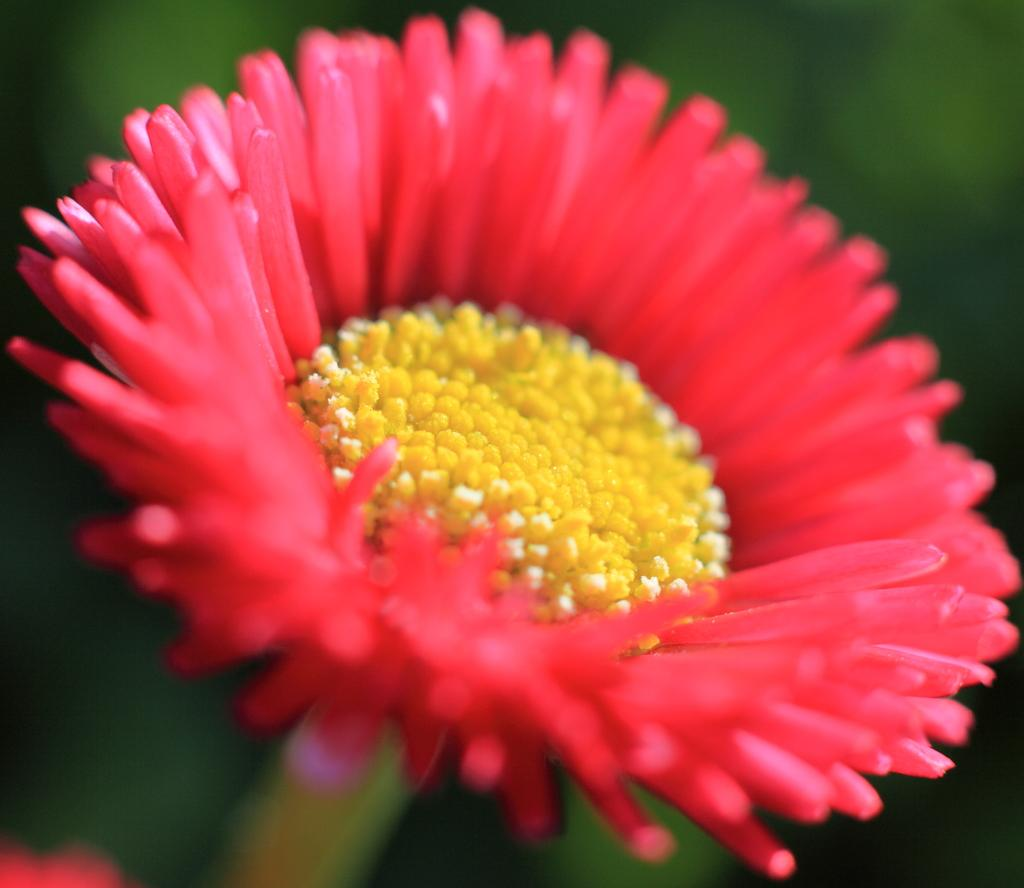What is the main subject of the image? There is a flower in the image. How many legs does the flower have in the image? Flowers do not have legs, so this question cannot be answered. 